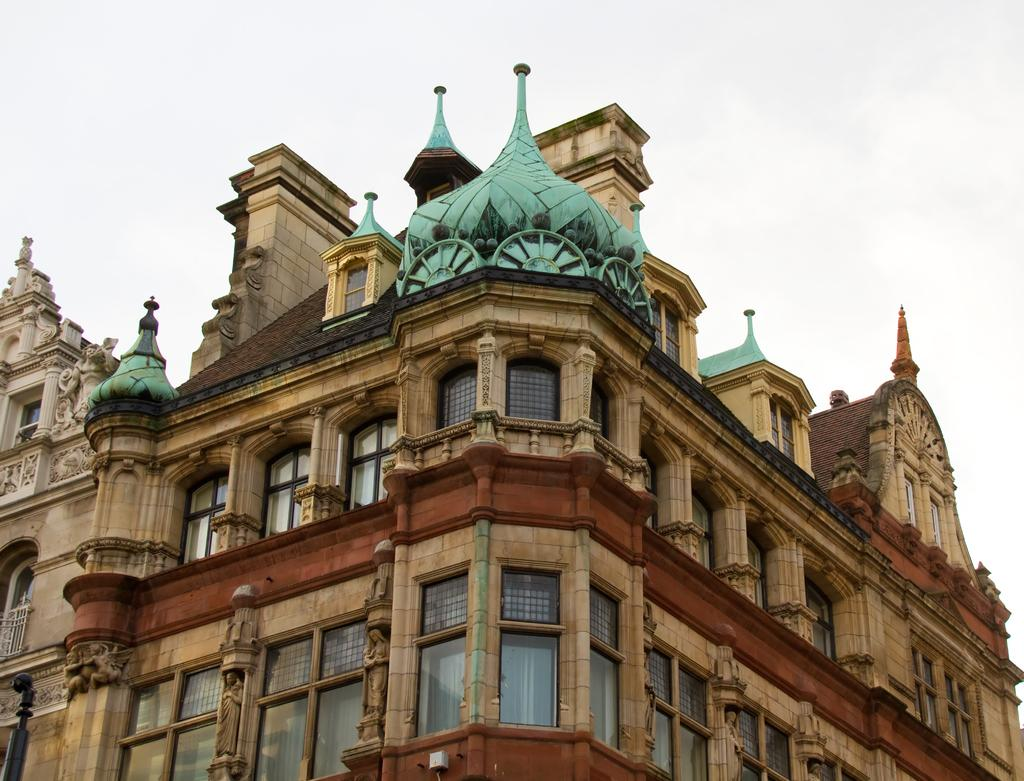What is the main structure in the image? There is a building in the image. What feature can be seen on the building? The building has windows. What can be seen inside the building through the windows? Curtains are visible through the windows. How would you describe the weather based on the image? The sky is cloudy in the image. How many trucks are parked in front of the building in the image? There are no trucks visible in the image; it only shows a building with windows and curtains. What type of beds can be seen in the representative's office in the image? There is no representative or office present in the image; it only shows a building with windows and curtains. 